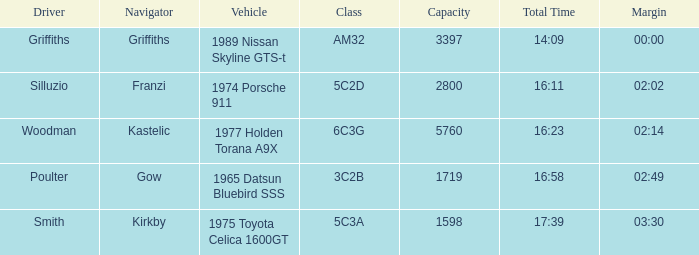Which driver recorded a combined time of 16:58? Poulter. 